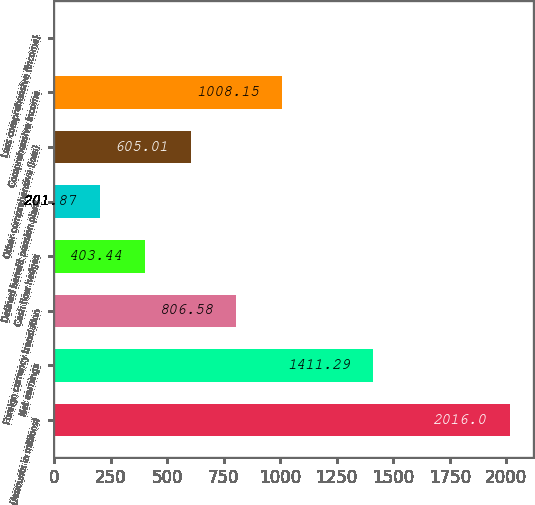<chart> <loc_0><loc_0><loc_500><loc_500><bar_chart><fcel>(Amounts in millions)<fcel>Net earnings<fcel>Foreign currency translation<fcel>Cash flow hedges<fcel>Defined benefit pension plans<fcel>Other comprehensive (loss)<fcel>Comprehensive income<fcel>Less comprehensive (income)<nl><fcel>2016<fcel>1411.29<fcel>806.58<fcel>403.44<fcel>201.87<fcel>605.01<fcel>1008.15<fcel>0.3<nl></chart> 